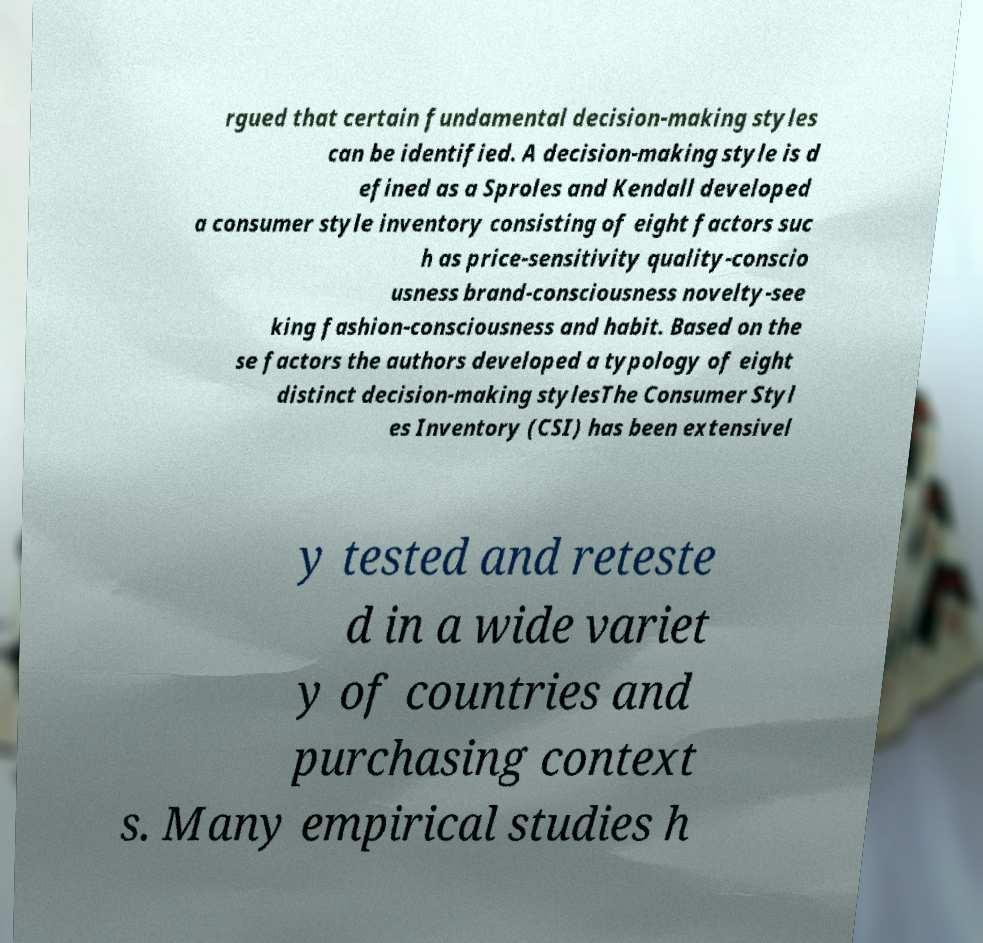Can you accurately transcribe the text from the provided image for me? rgued that certain fundamental decision-making styles can be identified. A decision-making style is d efined as a Sproles and Kendall developed a consumer style inventory consisting of eight factors suc h as price-sensitivity quality-conscio usness brand-consciousness novelty-see king fashion-consciousness and habit. Based on the se factors the authors developed a typology of eight distinct decision-making stylesThe Consumer Styl es Inventory (CSI) has been extensivel y tested and reteste d in a wide variet y of countries and purchasing context s. Many empirical studies h 